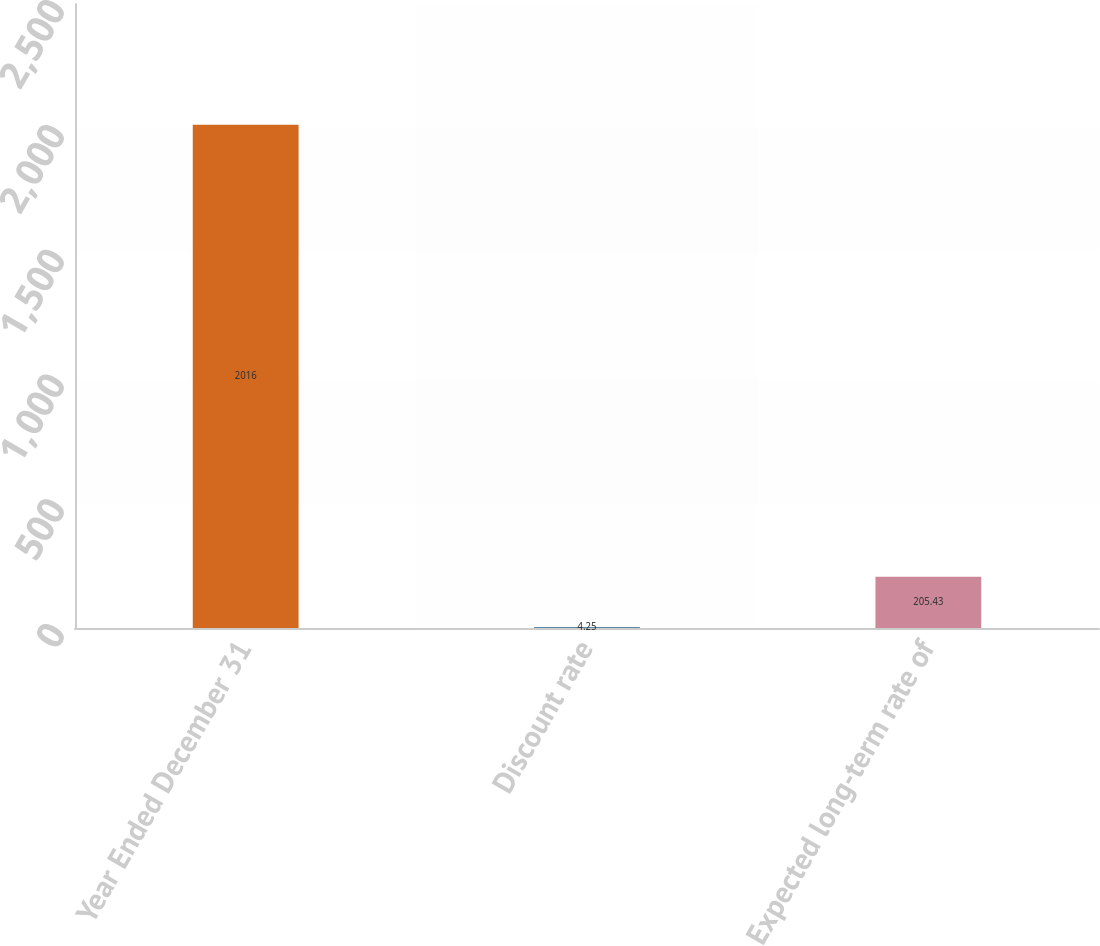Convert chart to OTSL. <chart><loc_0><loc_0><loc_500><loc_500><bar_chart><fcel>Year Ended December 31<fcel>Discount rate<fcel>Expected long-term rate of<nl><fcel>2016<fcel>4.25<fcel>205.43<nl></chart> 